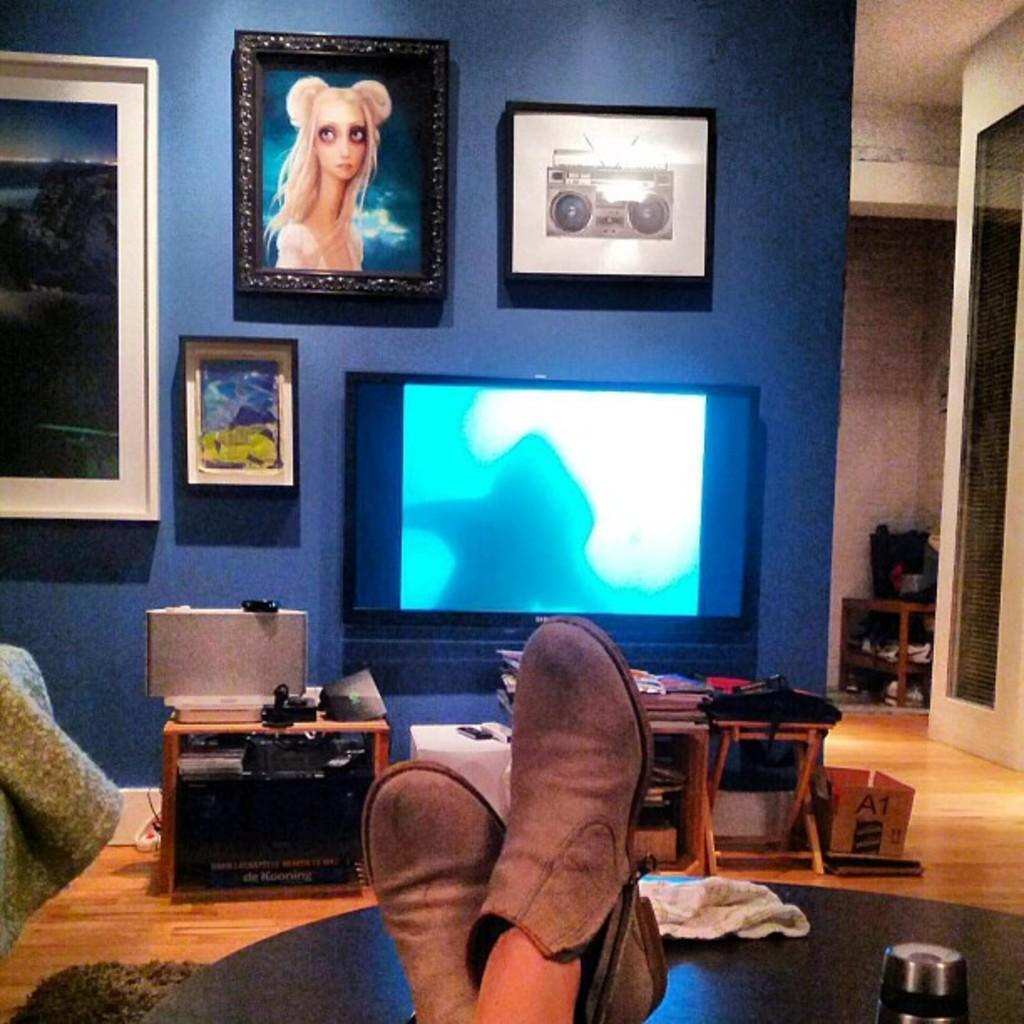Could you give a brief overview of what you see in this image? This is a picture taken in a home, This is a wooden floor on the floor there table on the table there are cloth, shoe and bottle. In front of the table there are shelves in the self's there are books, bag and some items and a television. Background of this television is a blue wall with photo frames. 